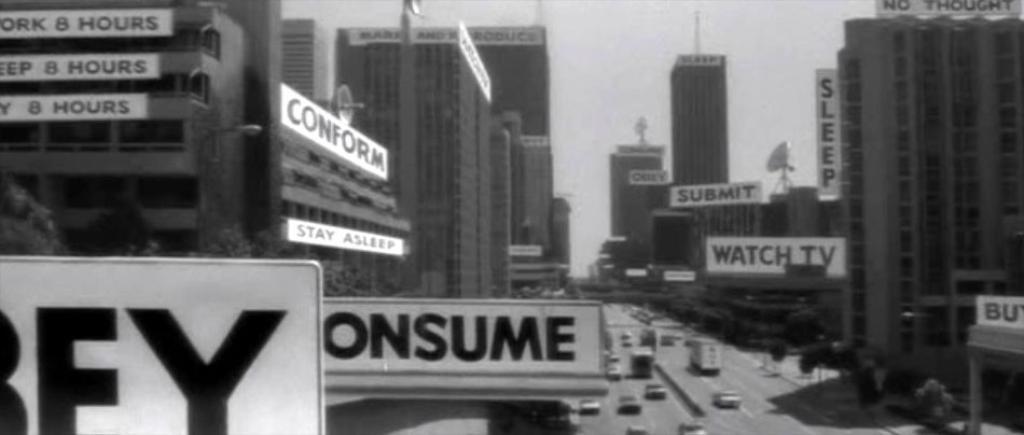How would you summarize this image in a sentence or two? In the picture we can see a black and white photograph of the city with many buildings and middle of it we can see a road with vehicles on it and near to the roads we can see a path with some plants and in the background we can see a sky. 